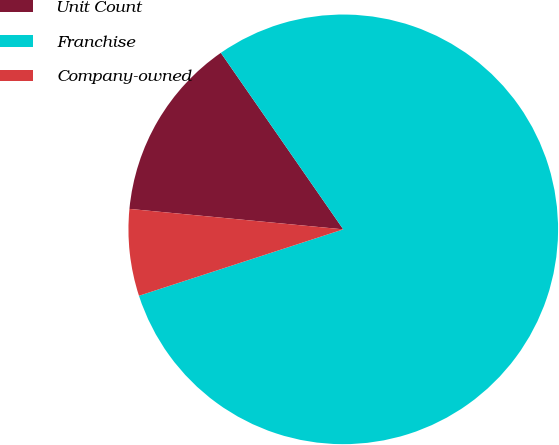Convert chart to OTSL. <chart><loc_0><loc_0><loc_500><loc_500><pie_chart><fcel>Unit Count<fcel>Franchise<fcel>Company-owned<nl><fcel>13.83%<fcel>79.64%<fcel>6.52%<nl></chart> 